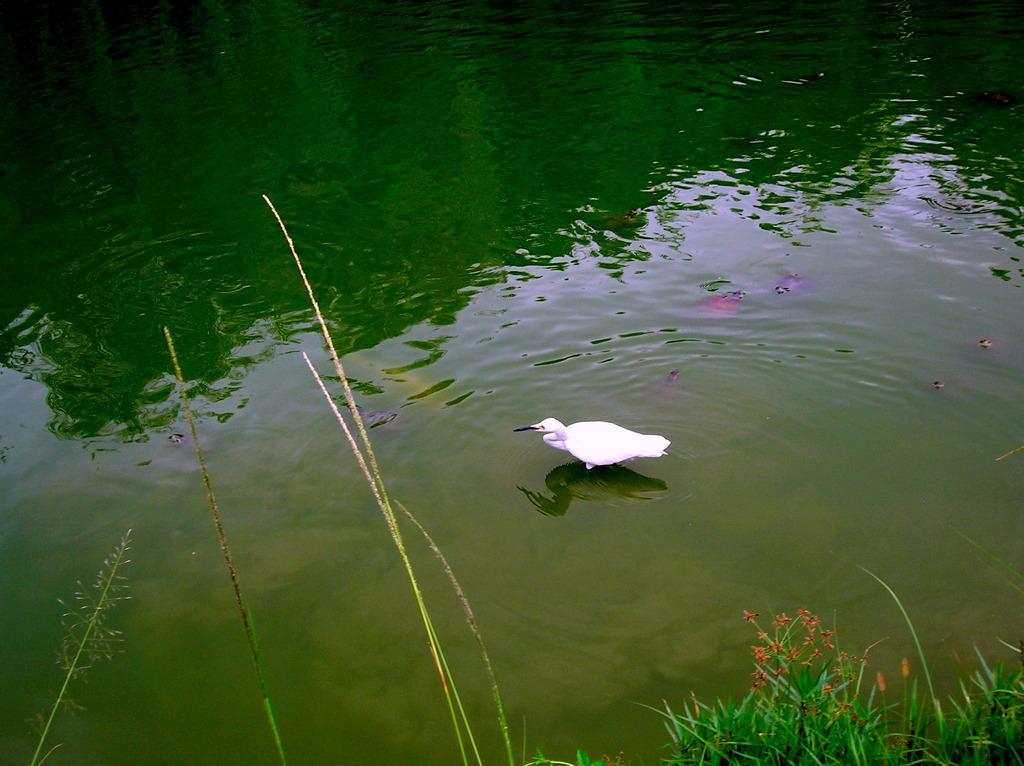What type of animals can be seen in the water in the image? There are fishes in the water in the image. What other animal can be seen in the image? There is a bird in the middle of the image. What can be found at the bottom of the image? There are plants at the bottom of the image. What type of bulb is being used to light up the duck in the image? There is no duck or bulb present in the image; it features fishes in the water and a bird. 